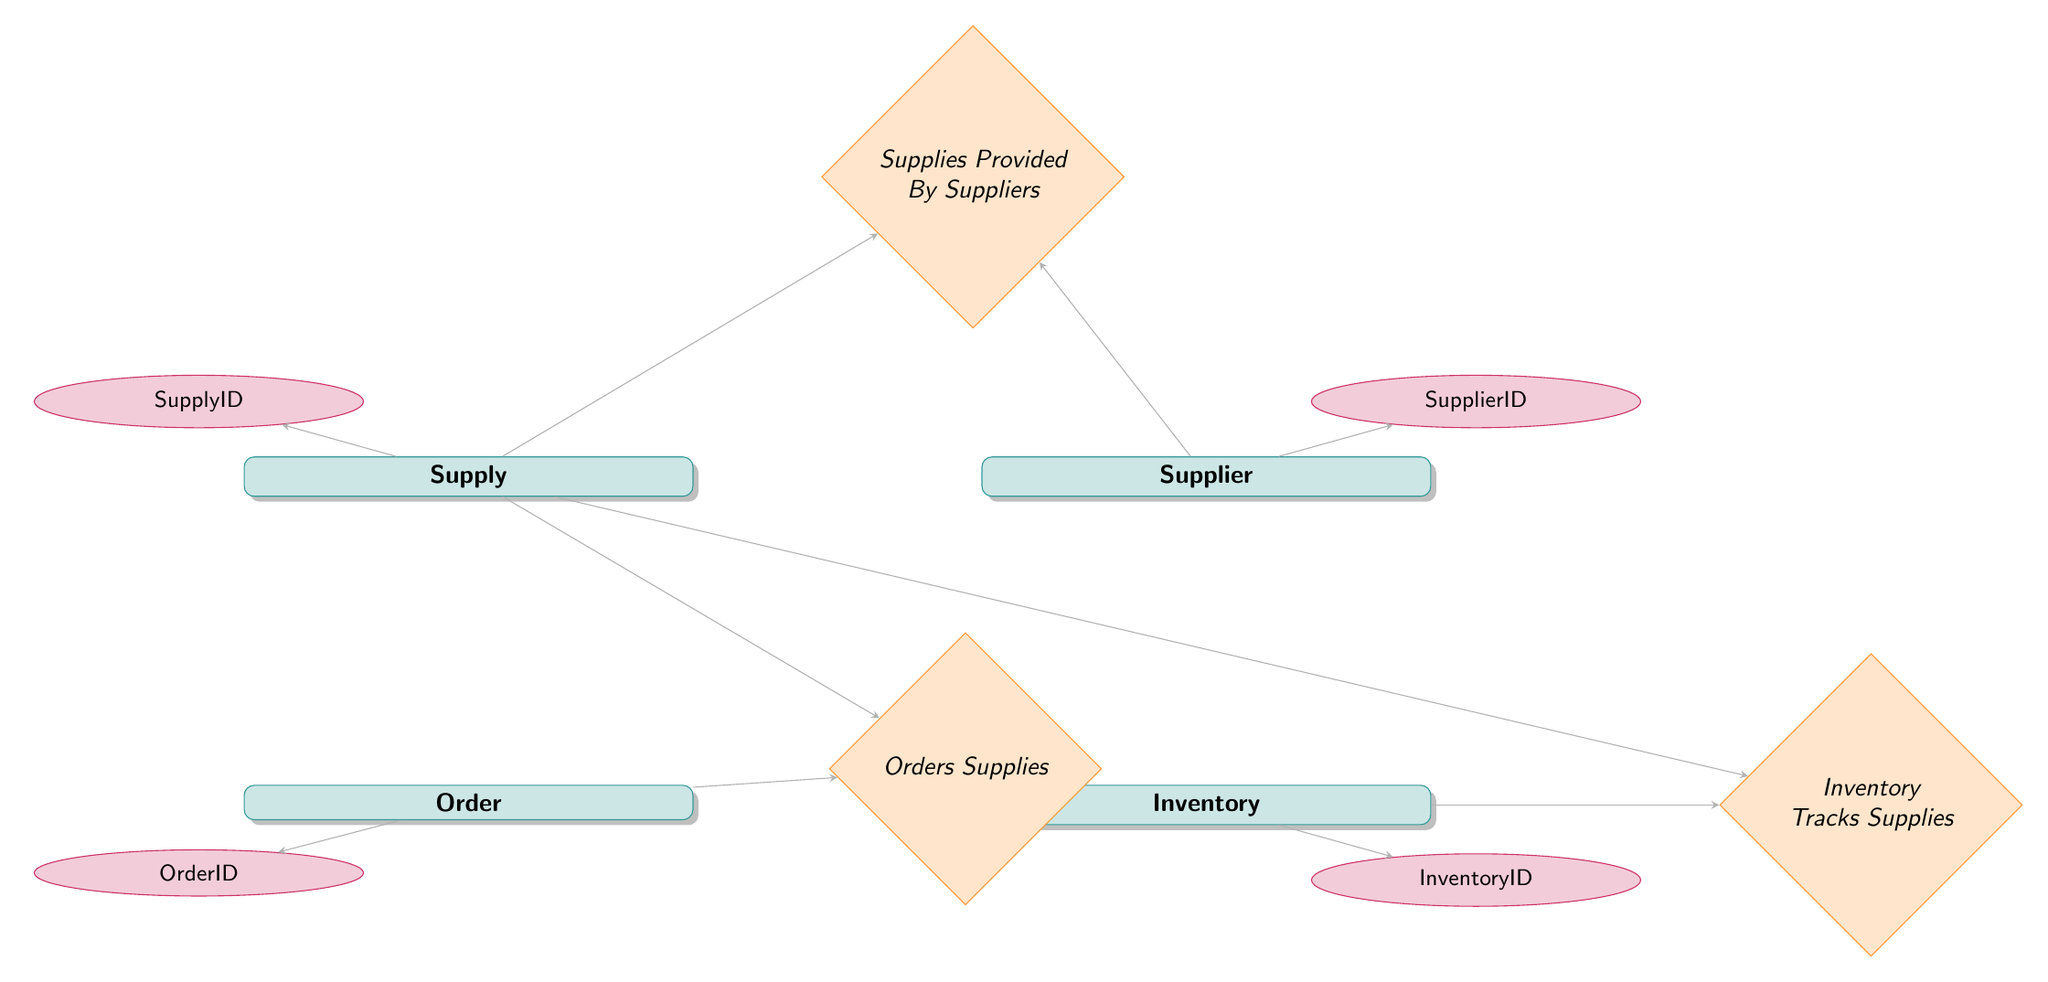what is the primary key of the Supply entity? The primary key of the Supply entity is SupplyID, which uniquely identifies each supply item in the inventory.
Answer: SupplyID how many relationships are present in the diagram? There are three relationships depicted in the diagram: "Supplies Provided By Suppliers", "Orders Supplies", and "Inventory Tracks Supplies". These relationships connect the entities based on their interactions.
Answer: 3 which entities are involved in the relationship "Orders Supplies"? The entities involved in the "Orders Supplies" relationship are Order and Supply. This relationship indicates that orders can contain multiple supplies, and supplies can be part of multiple orders.
Answer: Order and Supply what attribute of the Supplier entity contains contact information? The attribute of the Supplier entity that contains contact information is ContactInfo. It holds the details required to reach out to the supplier.
Answer: ContactInfo how is Inventory related to Supply in the diagram? Inventory is related to Supply through a one-to-many relationship called "Inventory Tracks Supplies". This implies that each supply item can be tracked through multiple inventory records, but each inventory record refers to only one supply item.
Answer: One-to-Many what is the role of SupplierID in the relationship "Supplies Provided By Suppliers"? SupplierID serves as a foreign key in the relationship "Supplies Provided By Suppliers". It links the Supplier entity to the Supply entity, establishing which suppliers provide which supplies.
Answer: Foreign Key how many attributes are listed for the Order entity? The Order entity has three attributes: OrderID, OrderDate, and DeliveryDate. These attributes store essential information related to each order placed.
Answer: 3 which relationship connects Supply and Inventory? The relationship that connects Supply and Inventory is "Inventory Tracks Supplies". This relationship specifies that inventory records are maintained for each supply item.
Answer: Inventory Tracks Supplies what is the maximum cardinality of the relationship "Supplies Provided By Suppliers"? The maximum cardinality of the relationship "Supplies Provided By Suppliers" is many-to-many, indicating that a single supply can be provided by multiple suppliers, and a single supplier can provide multiple supplies.
Answer: Many-to-Many 